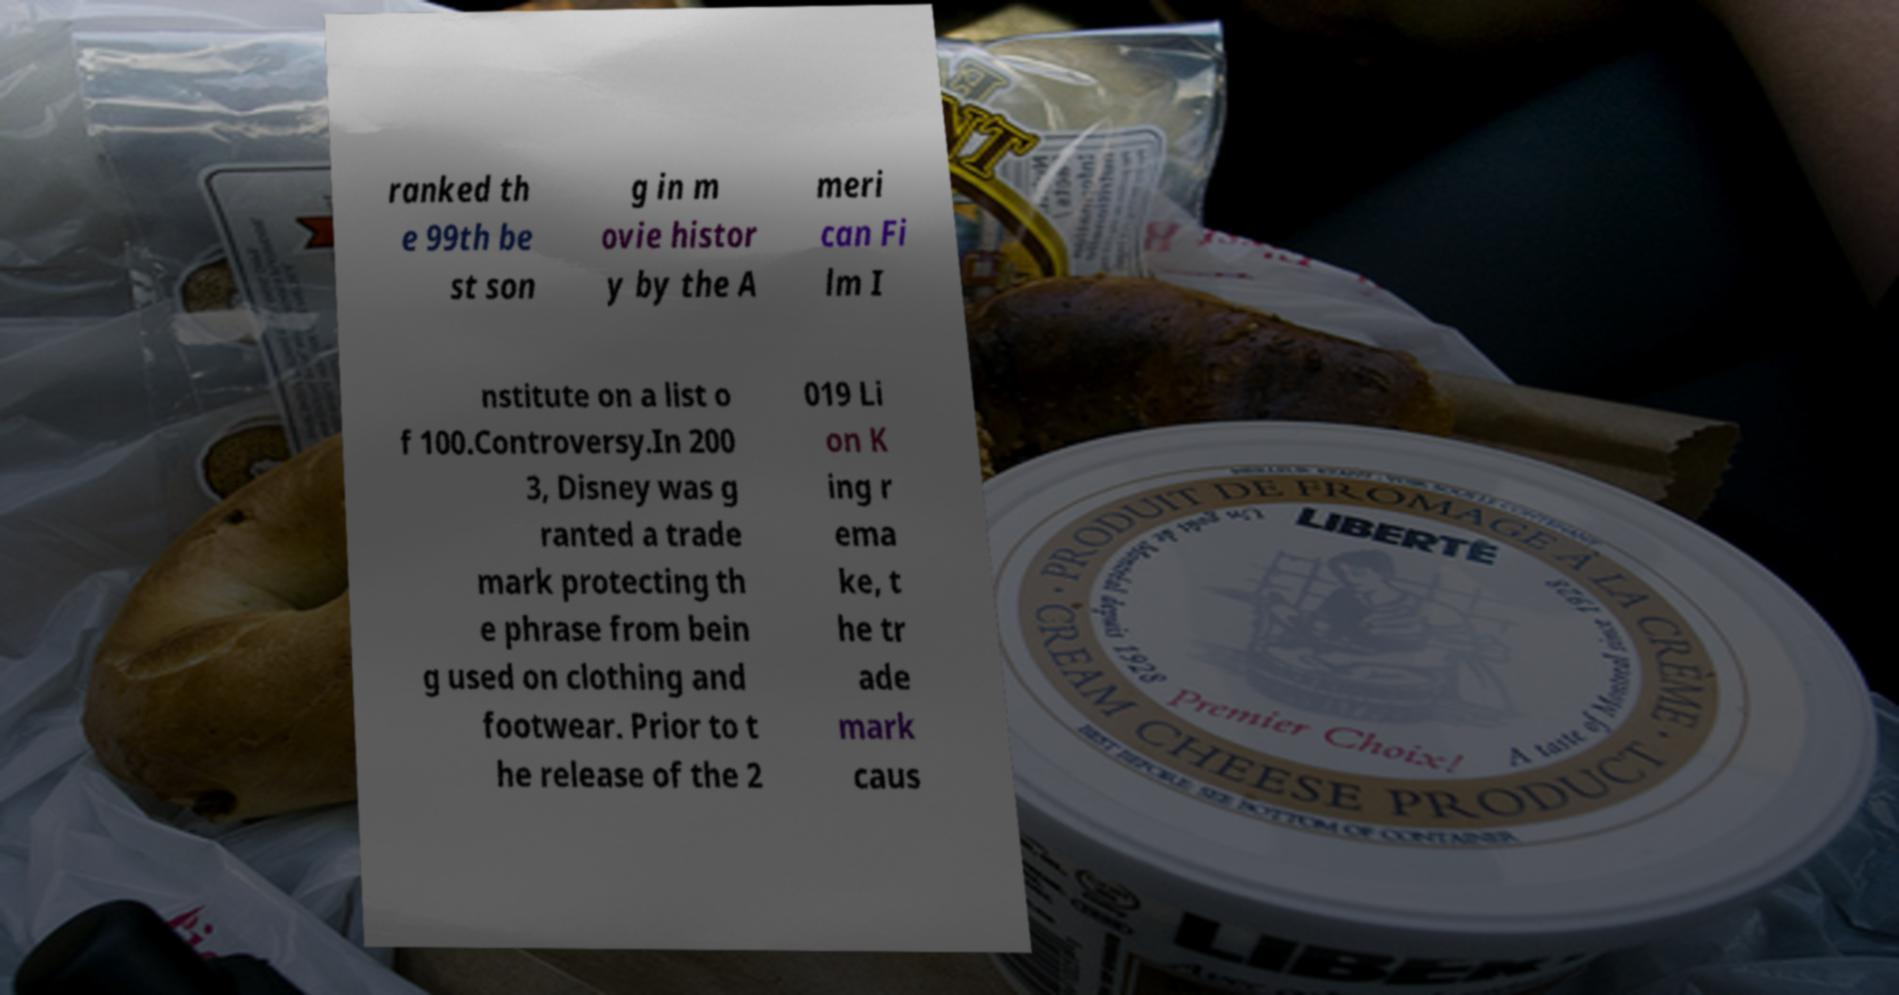Could you extract and type out the text from this image? ranked th e 99th be st son g in m ovie histor y by the A meri can Fi lm I nstitute on a list o f 100.Controversy.In 200 3, Disney was g ranted a trade mark protecting th e phrase from bein g used on clothing and footwear. Prior to t he release of the 2 019 Li on K ing r ema ke, t he tr ade mark caus 